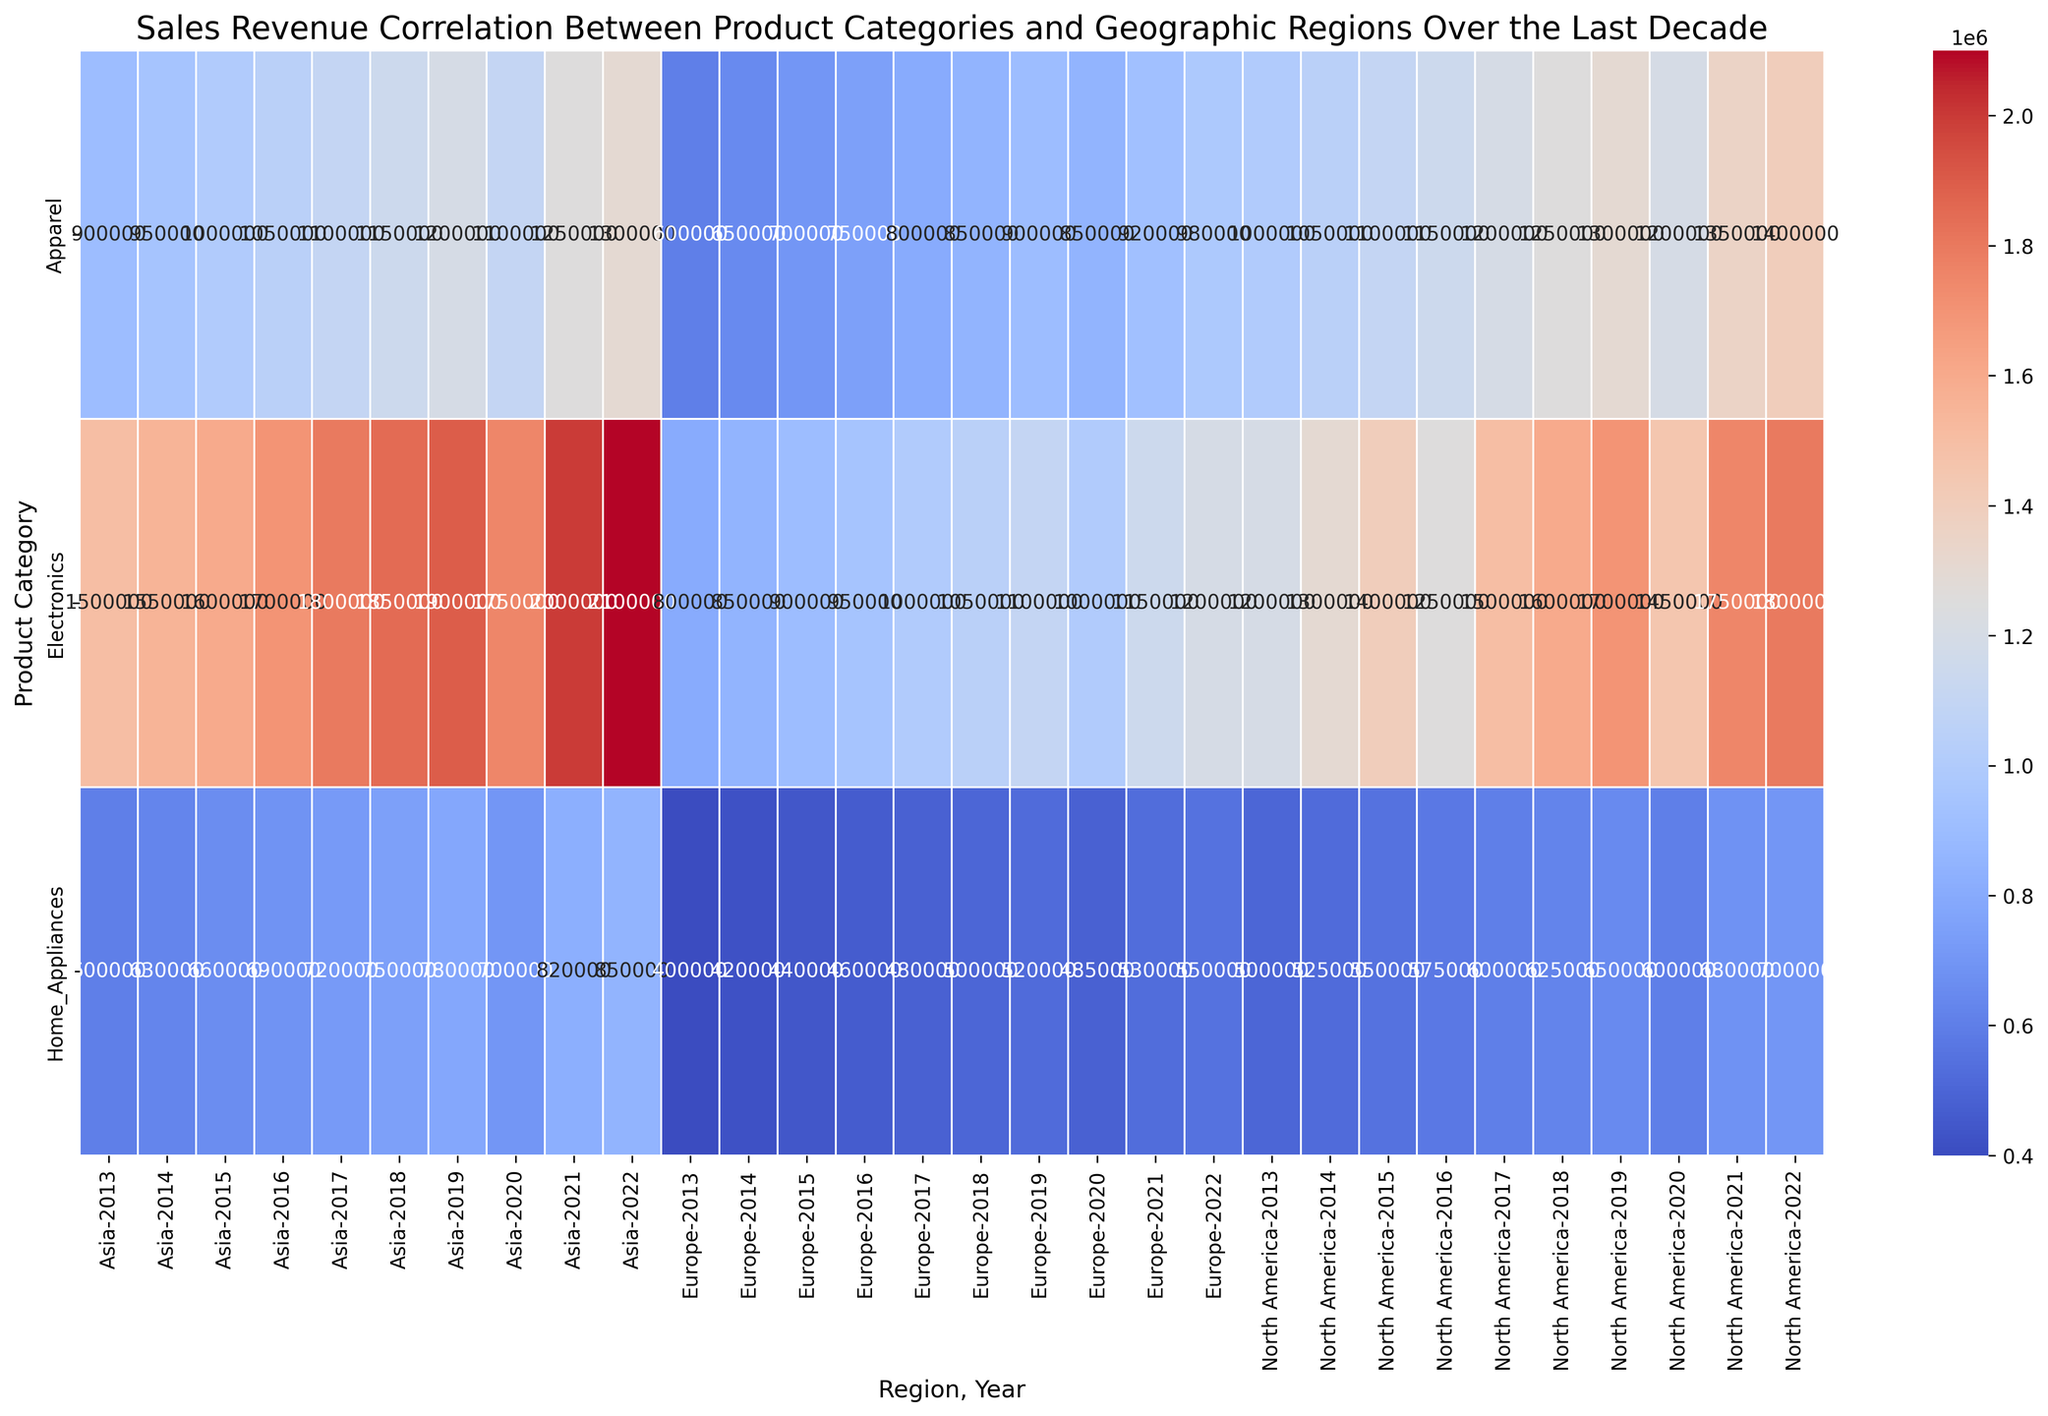Which product category had the highest sales revenue in Asia in 2022? Look at the vertical axis for product categories and then find the intersection with Asia in 2022. The highest sales revenue will be the one with the darkest shade. Electronics has the highest value.
Answer: Electronics Compare the sales revenue of Home Appliances in North America between 2018 and 2022. Which year had higher revenue? Compare the numerical values in the Home Appliances row under North America for the years 2018 and 2022. The revenue in 2022 is 700000, whereas in 2018 it is 625000, so 2022 had higher revenue.
Answer: 2022 What is the average sales revenue for Apparel in Europe from 2018 to 2022? Identify the sales revenue numbers for Apparel in Europe for the years 2018 (850000), 2019 (900000), 2020 (850000), 2021 (920000), and 2022 (980000). Sum these values and divide by 5. (850000 + 900000 + 850000 + 920000 + 980000) / 5 = 900000
Answer: 900000 Did the annual sales revenue of Electronics in North America ever decrease from one year to the next? Observe the sales revenue for Electronics in North America year by year. Between 2015 and 2016, revenue decreased from 1400000 to 1250000.
Answer: Yes Which region showed the most significant increase in sales revenue for Home Appliances from 2020 to 2021? Check the changes in sales revenue for Home Appliances between 2020 to 2021 for all regions. The increase is 80000 (600000 to 680000) in North America, 45000 (485000 to 530000) in Europe, and 120000 (700000 to 820000) in Asia. Asia has the highest increase.
Answer: Asia What is the total sales revenue for Electronics in 2021 across all regions? Add up the sales revenues of Electronics for the year 2021 in all regions: North America (1750000), Europe (1150000), Asia (2000000). (1750000 + 1150000 + 2000000) = 4900000
Answer: 4900000 